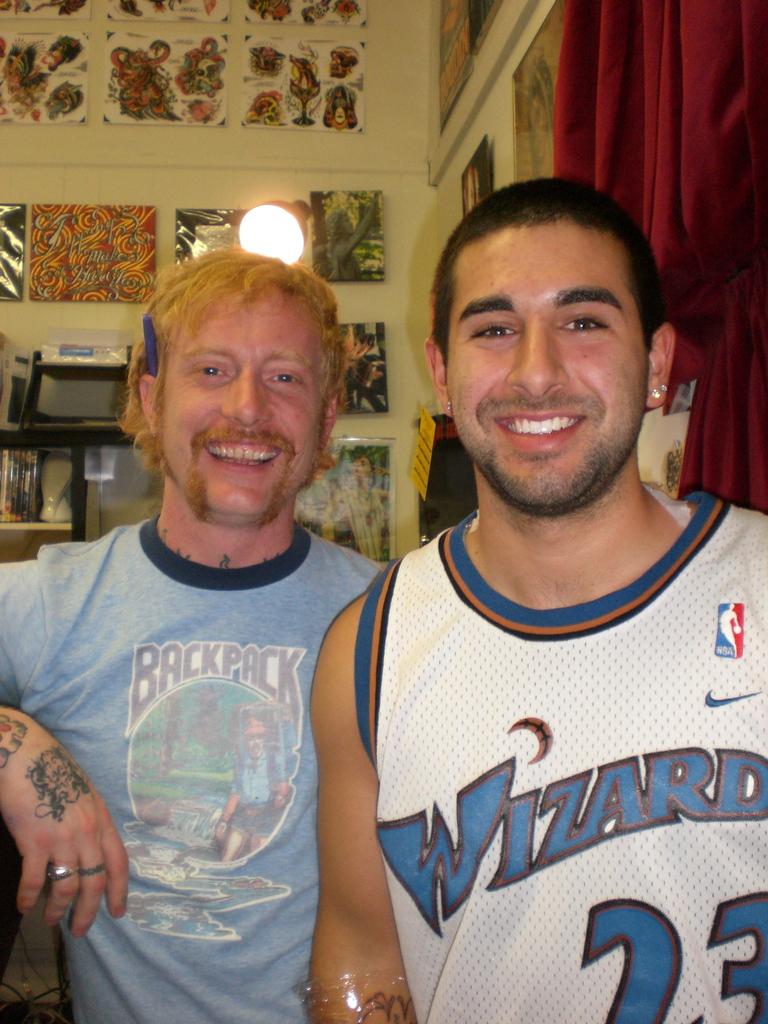What basketball team is on the jersey?
Your answer should be very brief. Wizards. 